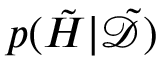Convert formula to latex. <formula><loc_0><loc_0><loc_500><loc_500>p ( \tilde { H } | \tilde { \mathcal { D } } )</formula> 